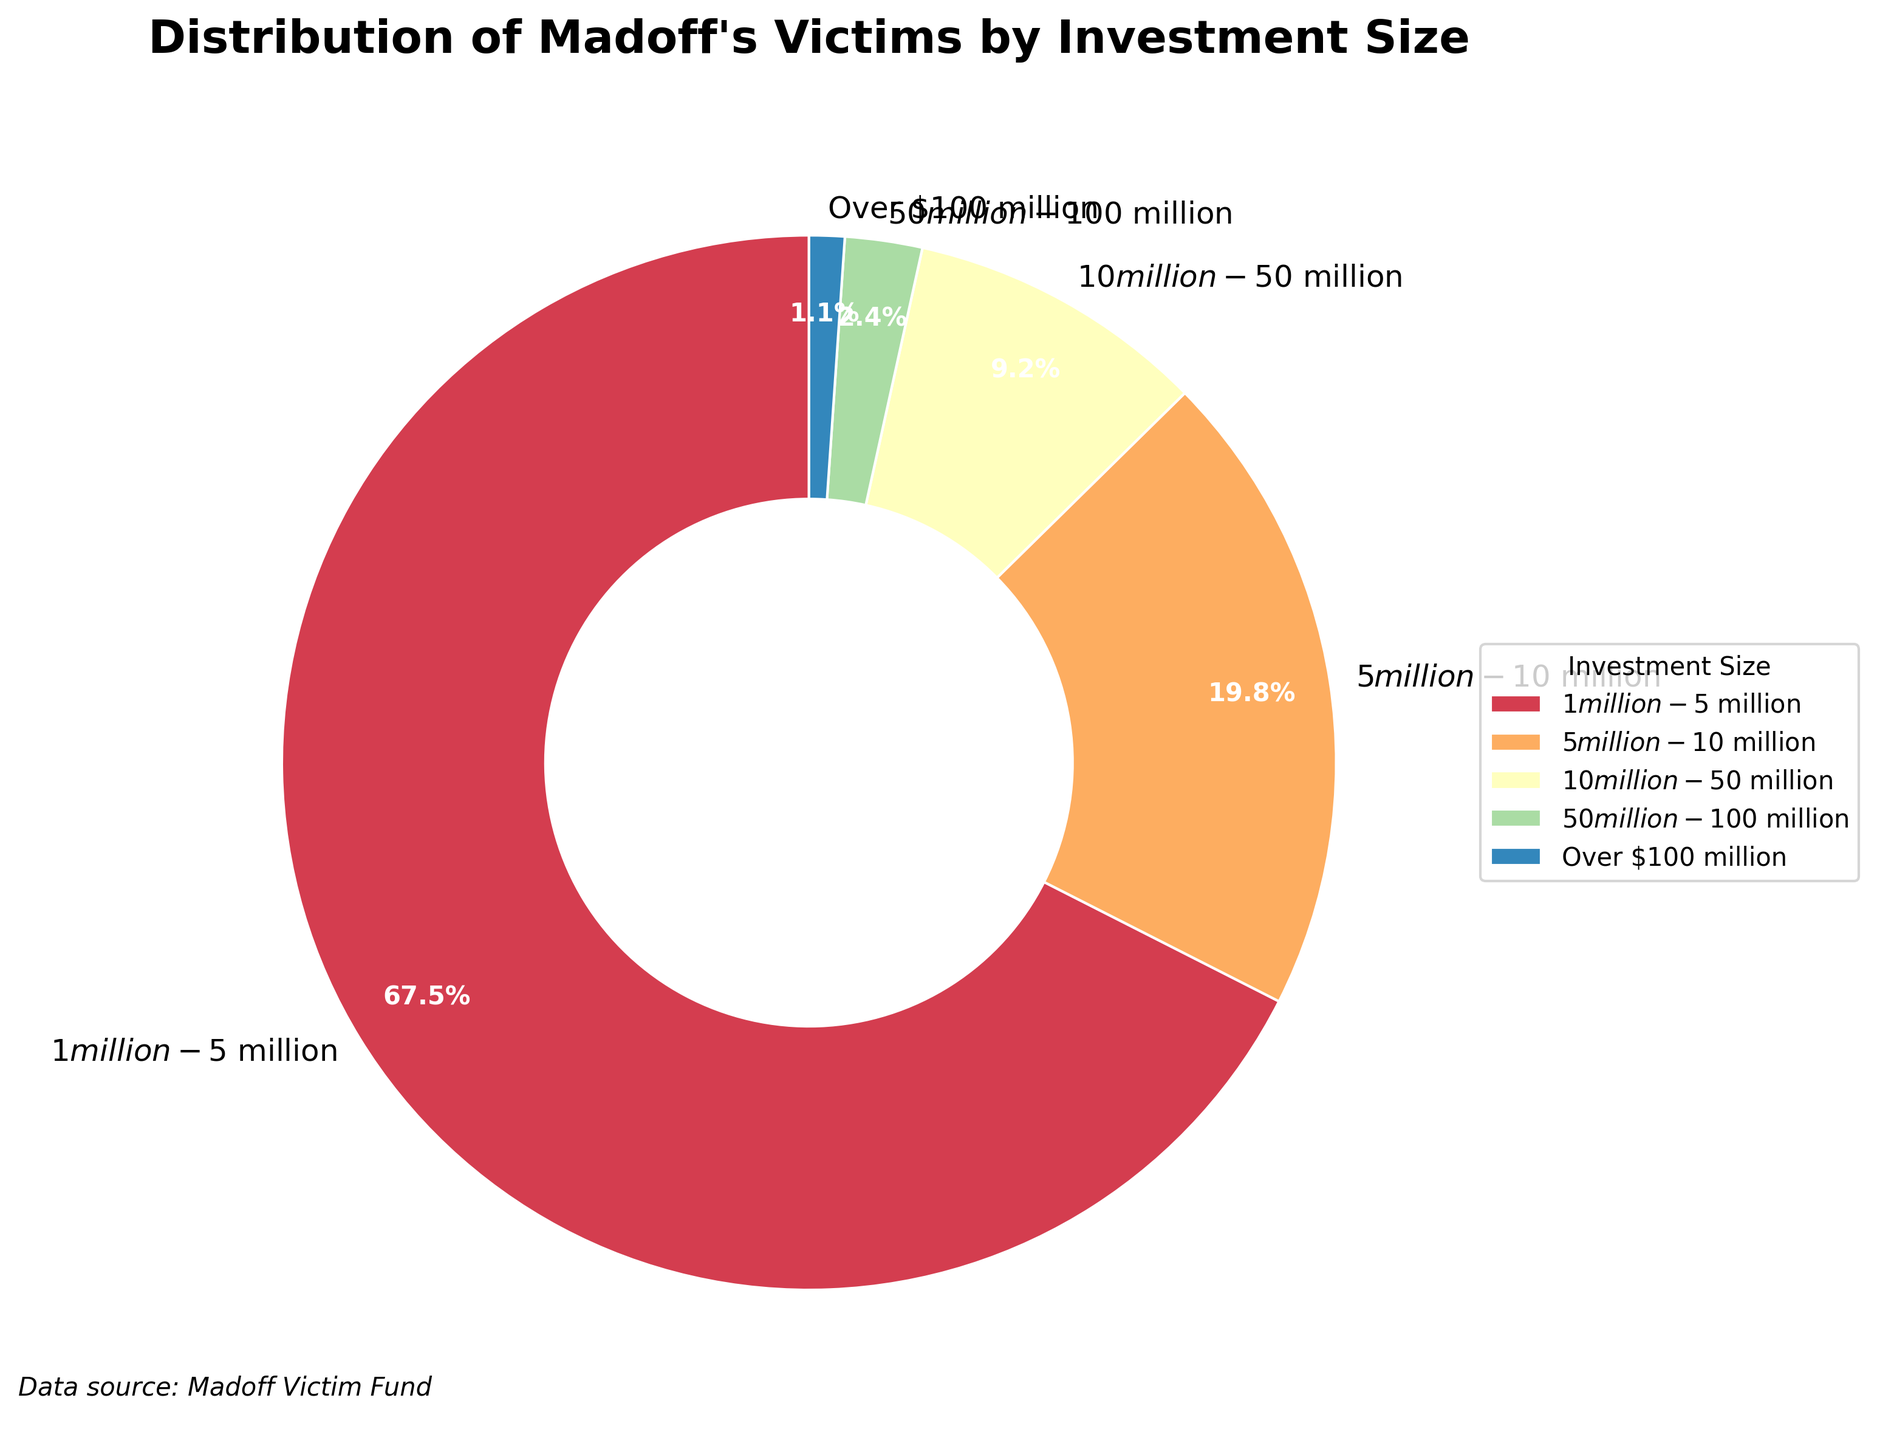Which investment size category had the highest number of victims? The investment size category with the highest number of victims can be identified by looking at the largest portion of the pie chart. The $1 million to $5 million category covers the largest section.
Answer: $1 million - $5 million What percentage of victims had investments over $50 million? To determine this, combine the percentages of the $50 million - $100 million and Over $100 million segments and read the values from the pie chart. These are 2.6% and 1.2%, respectively. Adding these gives 3.8%.
Answer: 3.8% How many more victims are there in the $1 million - $5 million category compared to the $5 million - $10 million category? Find the number of victims in each category from the data. The $1 million - $5 million category has 684 victims, while the $5 million - $10 million category has 201 victims. Subtract the latter from the former: 684 - 201.
Answer: 483 Which category has the smallest number of victims, and what is the exact number? The smallest portion of the pie chart corresponds to the category Over $100 million. According to the data, this category has 11 victims.
Answer: Over $100 million, 11 victims How many more victims had investments between $1 million and $50 million compared to those with investments over $50 million? Sum the victims in the $1 million - $5 million, $5 million - $10 million, and $10 million - $50 million categories: 684 + 201 + 93 = 978. Then, sum the victims in the $50 million - $100 million and Over $100 million categories: 24 + 11 = 35. Subtract the latter sum from the former: 978 - 35.
Answer: 943 What fraction of the victims had investments of $10 million or more? Add the number of victims in the $10 million - $50 million, $50 million - $100 million, and Over $100 million categories: 93 + 24 + 11 = 128. Then, divide this by the total number of victims: 128 / (684 + 201 + 93 + 24 + 11).
Answer: 128 / 1013 Which visual feature indicates that the $1 million - $5 million category is the largest? The $1 million - $5 million category can be visually identified as the largest by the size of its wedge in the pie chart. It occupies the most space.
Answer: Size of wedge Is the sum of victims in the $5 million - $10 million and $50 million - $100 million categories greater than those in the $10 million - $50 million category? First, add 201 ($5 million - $10 million) and 24 ($50 million - $100 million) to get 225. Then, compare it with 93 ($10 million - $50 million). Since 225 is greater than 93, the sum is indeed greater.
Answer: Yes 